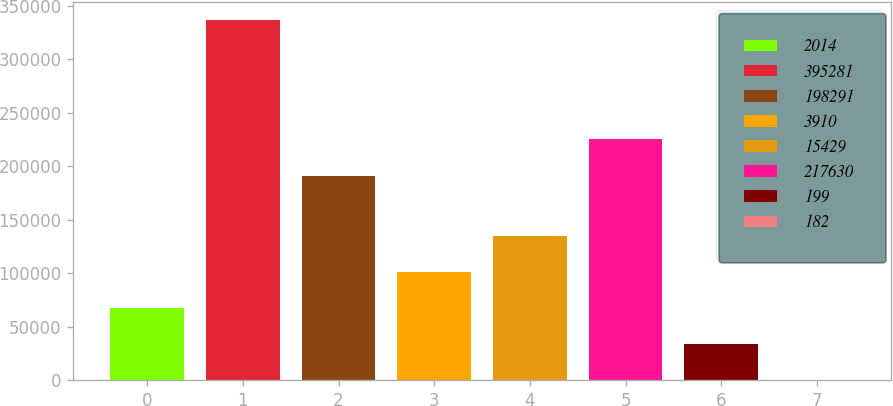<chart> <loc_0><loc_0><loc_500><loc_500><bar_chart><fcel>2014<fcel>395281<fcel>198291<fcel>3910<fcel>15429<fcel>217630<fcel>199<fcel>182<nl><fcel>67342.3<fcel>336705<fcel>191283<fcel>101013<fcel>134683<fcel>224953<fcel>33672<fcel>1.65<nl></chart> 